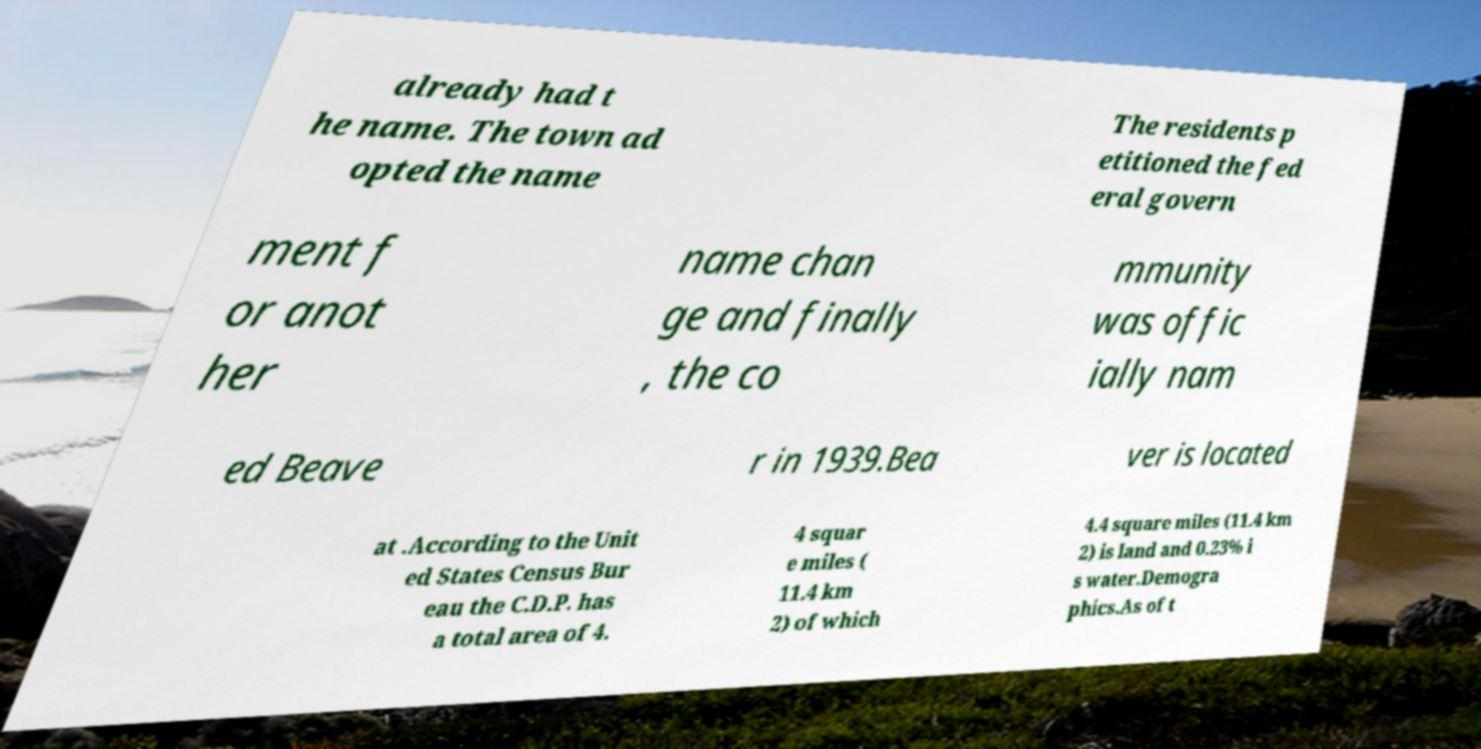Could you assist in decoding the text presented in this image and type it out clearly? already had t he name. The town ad opted the name The residents p etitioned the fed eral govern ment f or anot her name chan ge and finally , the co mmunity was offic ially nam ed Beave r in 1939.Bea ver is located at .According to the Unit ed States Census Bur eau the C.D.P. has a total area of 4. 4 squar e miles ( 11.4 km 2) of which 4.4 square miles (11.4 km 2) is land and 0.23% i s water.Demogra phics.As of t 